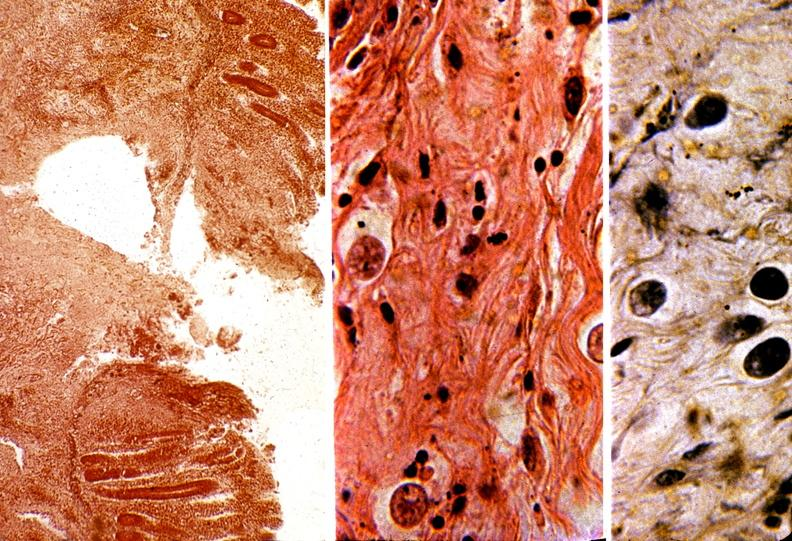where is this from?
Answer the question using a single word or phrase. Gastrointestinal system 